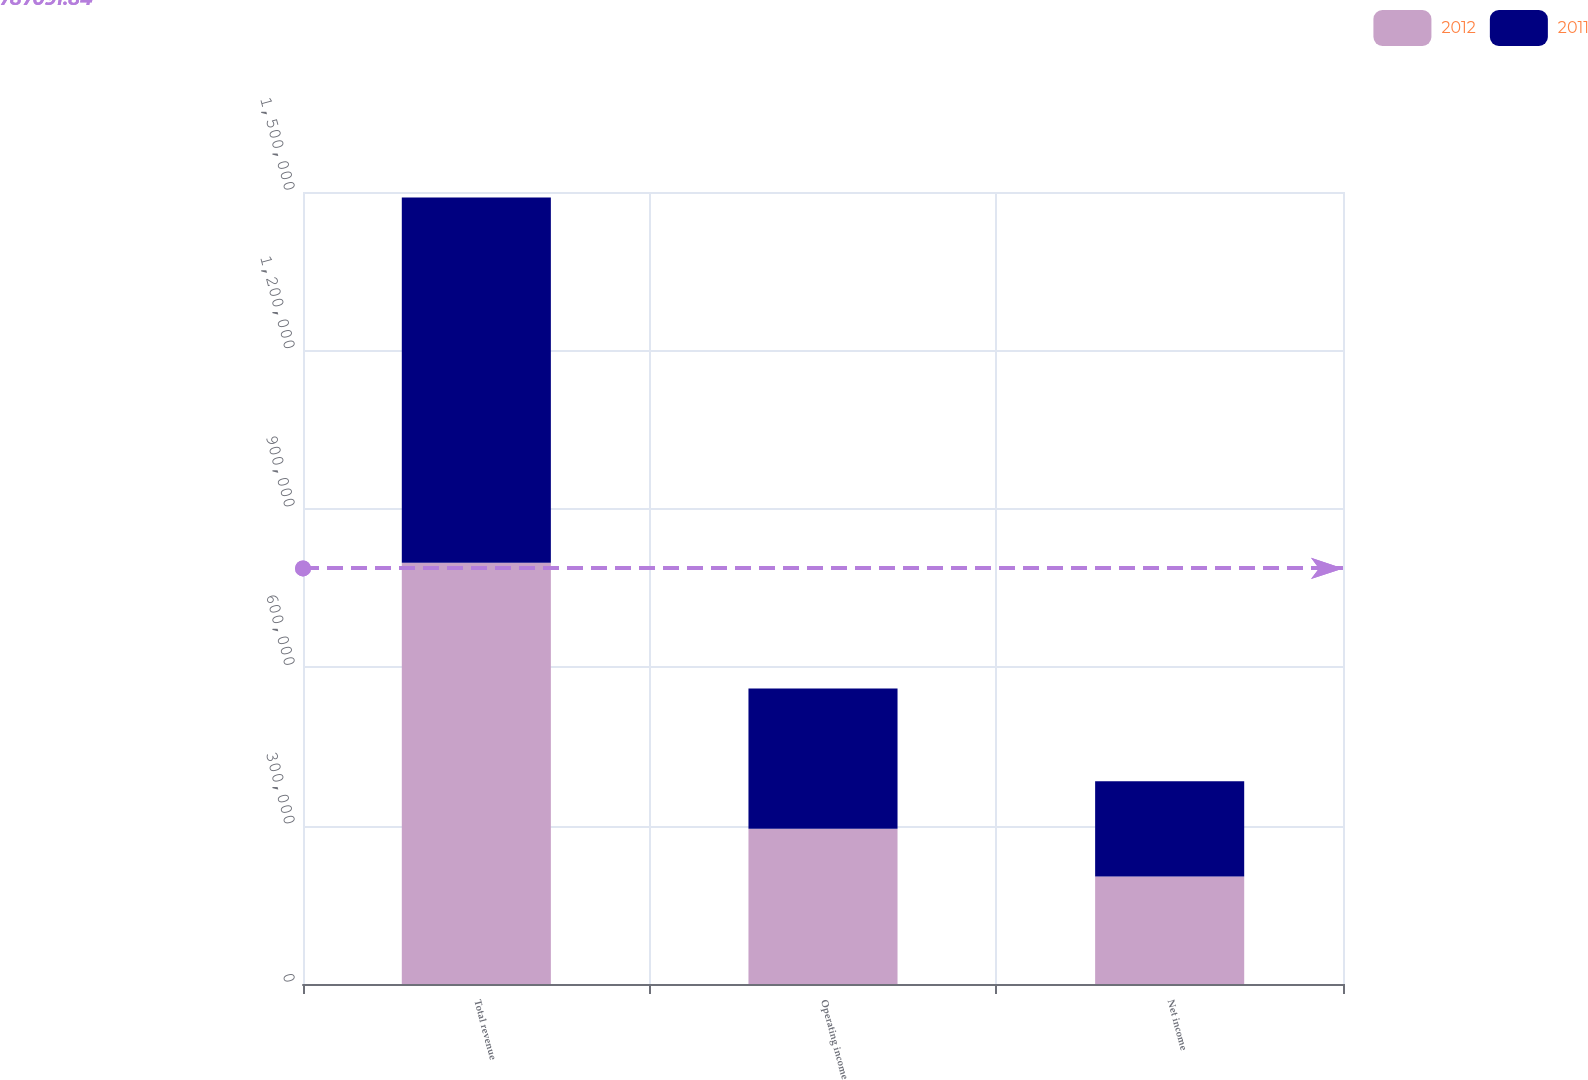Convert chart. <chart><loc_0><loc_0><loc_500><loc_500><stacked_bar_chart><ecel><fcel>Total revenue<fcel>Operating income<fcel>Net income<nl><fcel>2012<fcel>798018<fcel>294253<fcel>203483<nl><fcel>2011<fcel>691449<fcel>265559<fcel>180675<nl></chart> 